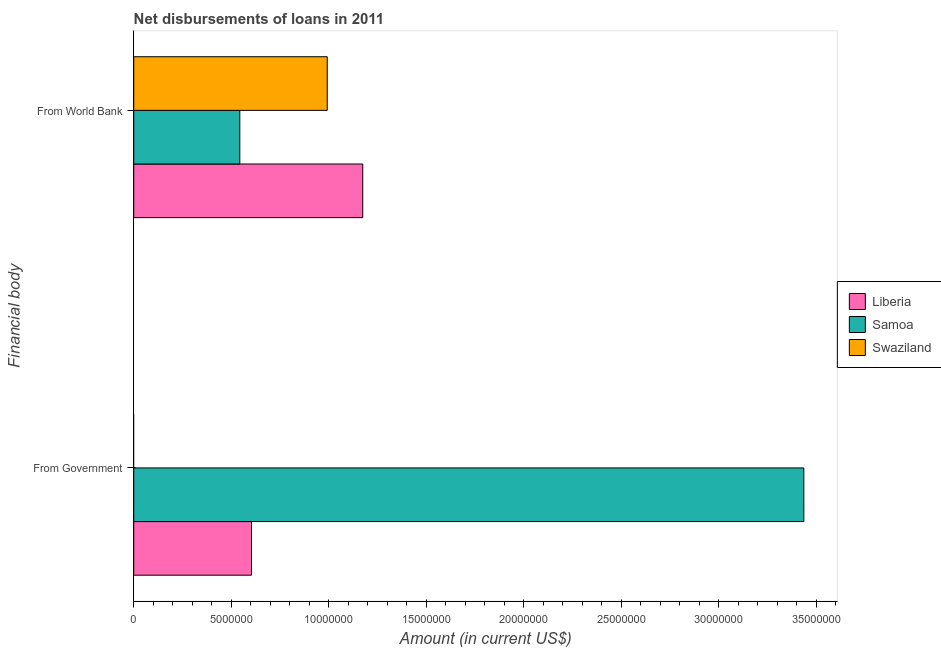How many groups of bars are there?
Keep it short and to the point. 2. How many bars are there on the 1st tick from the top?
Your response must be concise. 3. What is the label of the 1st group of bars from the top?
Give a very brief answer. From World Bank. What is the net disbursements of loan from government in Samoa?
Your answer should be very brief. 3.44e+07. Across all countries, what is the maximum net disbursements of loan from government?
Offer a terse response. 3.44e+07. Across all countries, what is the minimum net disbursements of loan from world bank?
Give a very brief answer. 5.44e+06. In which country was the net disbursements of loan from world bank maximum?
Ensure brevity in your answer.  Liberia. What is the total net disbursements of loan from world bank in the graph?
Keep it short and to the point. 2.71e+07. What is the difference between the net disbursements of loan from world bank in Samoa and that in Liberia?
Offer a terse response. -6.31e+06. What is the difference between the net disbursements of loan from world bank in Liberia and the net disbursements of loan from government in Swaziland?
Your answer should be very brief. 1.17e+07. What is the average net disbursements of loan from government per country?
Your answer should be compact. 1.35e+07. What is the difference between the net disbursements of loan from world bank and net disbursements of loan from government in Liberia?
Give a very brief answer. 5.71e+06. What is the ratio of the net disbursements of loan from world bank in Samoa to that in Liberia?
Give a very brief answer. 0.46. Is the net disbursements of loan from world bank in Liberia less than that in Samoa?
Keep it short and to the point. No. In how many countries, is the net disbursements of loan from world bank greater than the average net disbursements of loan from world bank taken over all countries?
Keep it short and to the point. 2. Are all the bars in the graph horizontal?
Offer a terse response. Yes. How many countries are there in the graph?
Keep it short and to the point. 3. Are the values on the major ticks of X-axis written in scientific E-notation?
Provide a succinct answer. No. Where does the legend appear in the graph?
Offer a terse response. Center right. How are the legend labels stacked?
Provide a short and direct response. Vertical. What is the title of the graph?
Give a very brief answer. Net disbursements of loans in 2011. What is the label or title of the X-axis?
Make the answer very short. Amount (in current US$). What is the label or title of the Y-axis?
Your response must be concise. Financial body. What is the Amount (in current US$) in Liberia in From Government?
Your answer should be very brief. 6.04e+06. What is the Amount (in current US$) of Samoa in From Government?
Provide a succinct answer. 3.44e+07. What is the Amount (in current US$) of Swaziland in From Government?
Your answer should be compact. 0. What is the Amount (in current US$) of Liberia in From World Bank?
Give a very brief answer. 1.17e+07. What is the Amount (in current US$) of Samoa in From World Bank?
Provide a succinct answer. 5.44e+06. What is the Amount (in current US$) in Swaziland in From World Bank?
Give a very brief answer. 9.92e+06. Across all Financial body, what is the maximum Amount (in current US$) in Liberia?
Offer a terse response. 1.17e+07. Across all Financial body, what is the maximum Amount (in current US$) in Samoa?
Offer a very short reply. 3.44e+07. Across all Financial body, what is the maximum Amount (in current US$) in Swaziland?
Offer a very short reply. 9.92e+06. Across all Financial body, what is the minimum Amount (in current US$) of Liberia?
Keep it short and to the point. 6.04e+06. Across all Financial body, what is the minimum Amount (in current US$) of Samoa?
Offer a terse response. 5.44e+06. What is the total Amount (in current US$) in Liberia in the graph?
Offer a very short reply. 1.78e+07. What is the total Amount (in current US$) in Samoa in the graph?
Provide a succinct answer. 3.98e+07. What is the total Amount (in current US$) of Swaziland in the graph?
Your answer should be compact. 9.92e+06. What is the difference between the Amount (in current US$) of Liberia in From Government and that in From World Bank?
Provide a short and direct response. -5.71e+06. What is the difference between the Amount (in current US$) in Samoa in From Government and that in From World Bank?
Offer a very short reply. 2.89e+07. What is the difference between the Amount (in current US$) of Liberia in From Government and the Amount (in current US$) of Samoa in From World Bank?
Your response must be concise. 5.99e+05. What is the difference between the Amount (in current US$) in Liberia in From Government and the Amount (in current US$) in Swaziland in From World Bank?
Keep it short and to the point. -3.88e+06. What is the difference between the Amount (in current US$) in Samoa in From Government and the Amount (in current US$) in Swaziland in From World Bank?
Your answer should be compact. 2.44e+07. What is the average Amount (in current US$) of Liberia per Financial body?
Give a very brief answer. 8.89e+06. What is the average Amount (in current US$) of Samoa per Financial body?
Offer a very short reply. 1.99e+07. What is the average Amount (in current US$) in Swaziland per Financial body?
Offer a terse response. 4.96e+06. What is the difference between the Amount (in current US$) of Liberia and Amount (in current US$) of Samoa in From Government?
Offer a terse response. -2.83e+07. What is the difference between the Amount (in current US$) in Liberia and Amount (in current US$) in Samoa in From World Bank?
Your answer should be very brief. 6.31e+06. What is the difference between the Amount (in current US$) of Liberia and Amount (in current US$) of Swaziland in From World Bank?
Make the answer very short. 1.82e+06. What is the difference between the Amount (in current US$) of Samoa and Amount (in current US$) of Swaziland in From World Bank?
Your answer should be compact. -4.48e+06. What is the ratio of the Amount (in current US$) of Liberia in From Government to that in From World Bank?
Make the answer very short. 0.51. What is the ratio of the Amount (in current US$) of Samoa in From Government to that in From World Bank?
Provide a short and direct response. 6.32. What is the difference between the highest and the second highest Amount (in current US$) of Liberia?
Your response must be concise. 5.71e+06. What is the difference between the highest and the second highest Amount (in current US$) of Samoa?
Provide a succinct answer. 2.89e+07. What is the difference between the highest and the lowest Amount (in current US$) in Liberia?
Keep it short and to the point. 5.71e+06. What is the difference between the highest and the lowest Amount (in current US$) in Samoa?
Your answer should be very brief. 2.89e+07. What is the difference between the highest and the lowest Amount (in current US$) of Swaziland?
Your answer should be compact. 9.92e+06. 